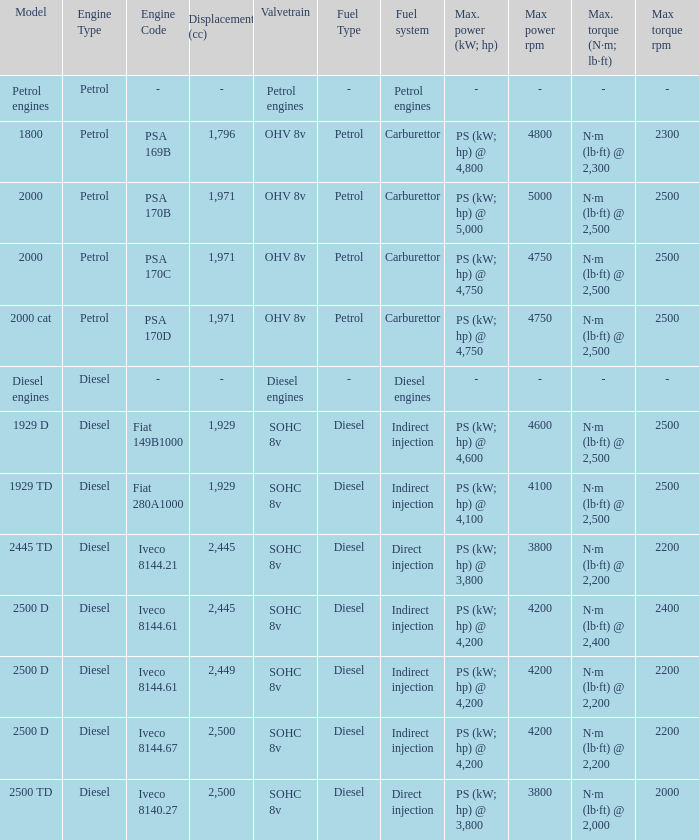What is the maximum torque that has 2,445 CC Displacement, and an Iveco 8144.61 engine? N·m (lb·ft) @ 2,400 rpm. Could you help me parse every detail presented in this table? {'header': ['Model', 'Engine Type', 'Engine Code', 'Displacement (cc)', 'Valvetrain', 'Fuel Type', 'Fuel system', 'Max. power (kW; hp)', 'Max power rpm', 'Max. torque (N·m; lb·ft)', 'Max torque rpm'], 'rows': [['Petrol engines', 'Petrol', '-', '-', 'Petrol engines', '-', 'Petrol engines', '-', '-', '-', '-'], ['1800', 'Petrol', 'PSA 169B', '1,796', 'OHV 8v', 'Petrol', 'Carburettor', 'PS (kW; hp) @ 4,800', '4800', 'N·m (lb·ft) @ 2,300', '2300'], ['2000', 'Petrol', 'PSA 170B', '1,971', 'OHV 8v', 'Petrol', 'Carburettor', 'PS (kW; hp) @ 5,000', '5000', 'N·m (lb·ft) @ 2,500', '2500'], ['2000', 'Petrol', 'PSA 170C', '1,971', 'OHV 8v', 'Petrol', 'Carburettor', 'PS (kW; hp) @ 4,750', '4750', 'N·m (lb·ft) @ 2,500', '2500'], ['2000 cat', 'Petrol', 'PSA 170D', '1,971', 'OHV 8v', 'Petrol', 'Carburettor', 'PS (kW; hp) @ 4,750', '4750', 'N·m (lb·ft) @ 2,500', '2500'], ['Diesel engines', 'Diesel', '-', '-', 'Diesel engines', '-', 'Diesel engines', '-', '-', '-', '-'], ['1929 D', 'Diesel', 'Fiat 149B1000', '1,929', 'SOHC 8v', 'Diesel', 'Indirect injection', 'PS (kW; hp) @ 4,600', '4600', 'N·m (lb·ft) @ 2,500', '2500'], ['1929 TD', 'Diesel', 'Fiat 280A1000', '1,929', 'SOHC 8v', 'Diesel', 'Indirect injection', 'PS (kW; hp) @ 4,100', '4100', 'N·m (lb·ft) @ 2,500', '2500'], ['2445 TD', 'Diesel', 'Iveco 8144.21', '2,445', 'SOHC 8v', 'Diesel', 'Direct injection', 'PS (kW; hp) @ 3,800', '3800', 'N·m (lb·ft) @ 2,200', '2200'], ['2500 D', 'Diesel', 'Iveco 8144.61', '2,445', 'SOHC 8v', 'Diesel', 'Indirect injection', 'PS (kW; hp) @ 4,200', '4200', 'N·m (lb·ft) @ 2,400', '2400'], ['2500 D', 'Diesel', 'Iveco 8144.61', '2,449', 'SOHC 8v', 'Diesel', 'Indirect injection', 'PS (kW; hp) @ 4,200', '4200', 'N·m (lb·ft) @ 2,200', '2200'], ['2500 D', 'Diesel', 'Iveco 8144.67', '2,500', 'SOHC 8v', 'Diesel', 'Indirect injection', 'PS (kW; hp) @ 4,200', '4200', 'N·m (lb·ft) @ 2,200', '2200'], ['2500 TD', 'Diesel', 'Iveco 8140.27', '2,500', 'SOHC 8v', 'Diesel', 'Direct injection', 'PS (kW; hp) @ 3,800', '3800', 'N·m (lb·ft) @ 2,000', '2000']]} 